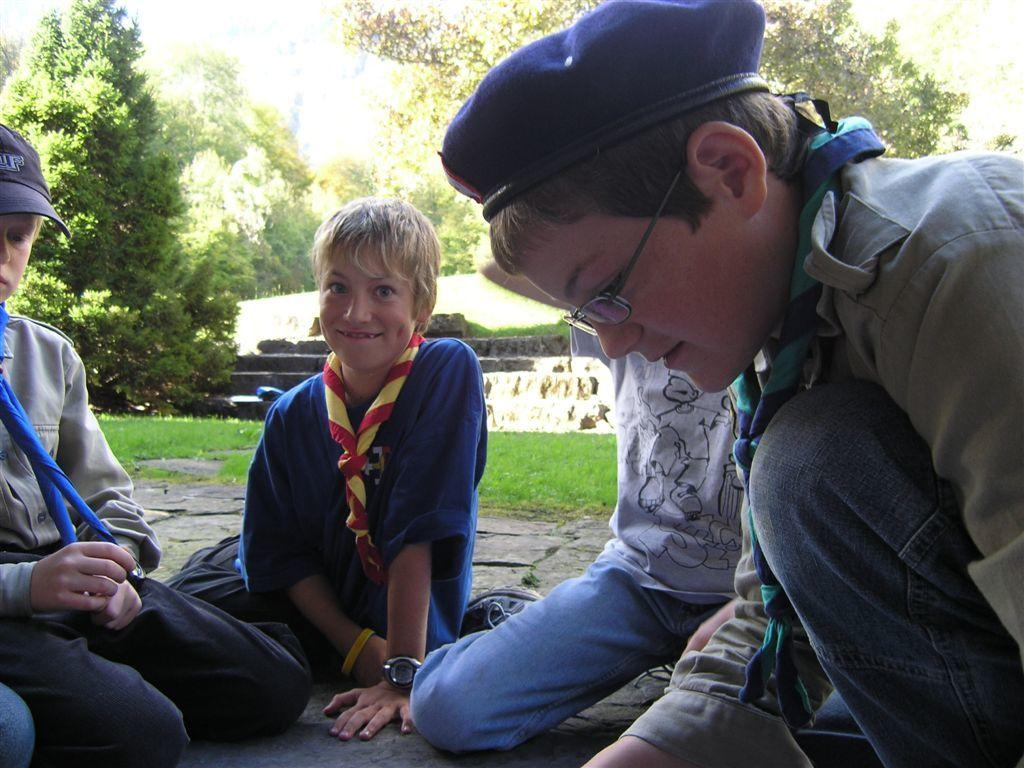What are the children doing in the image? The children are on the ground in the image. What can be seen in the background of the image? There are trees, stairs, and grass in the background of the image. What type of lock is being used to secure the tramp in the image? There is no tramp present in the image, so there is no lock to secure it. 